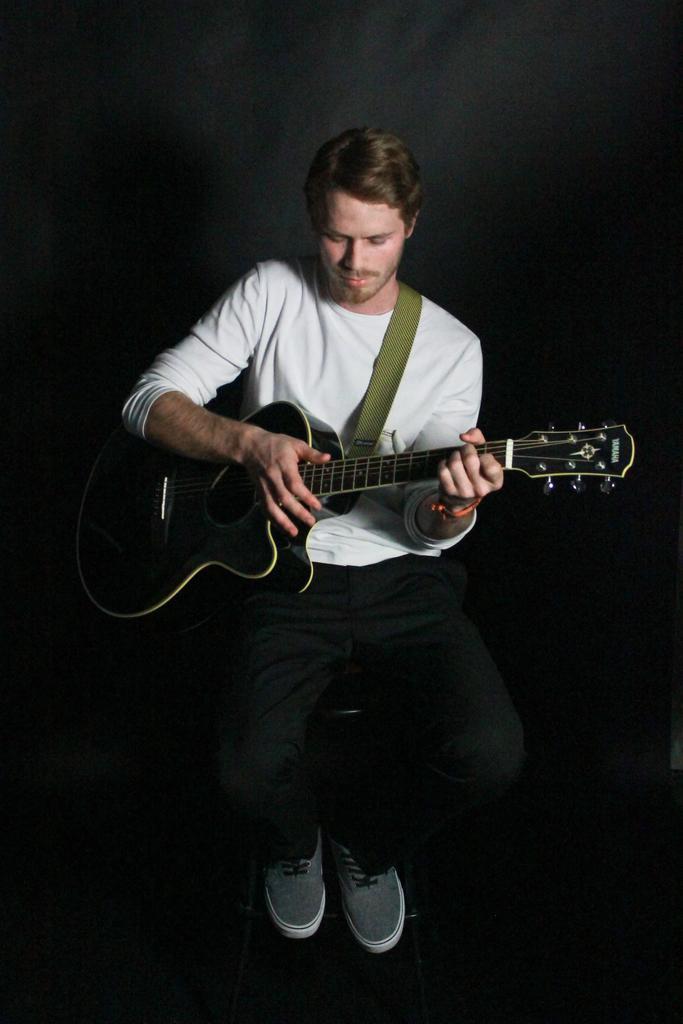How would you summarize this image in a sentence or two? In the image there is a man wearing a white color shirt holding a guitar and playing with it. 